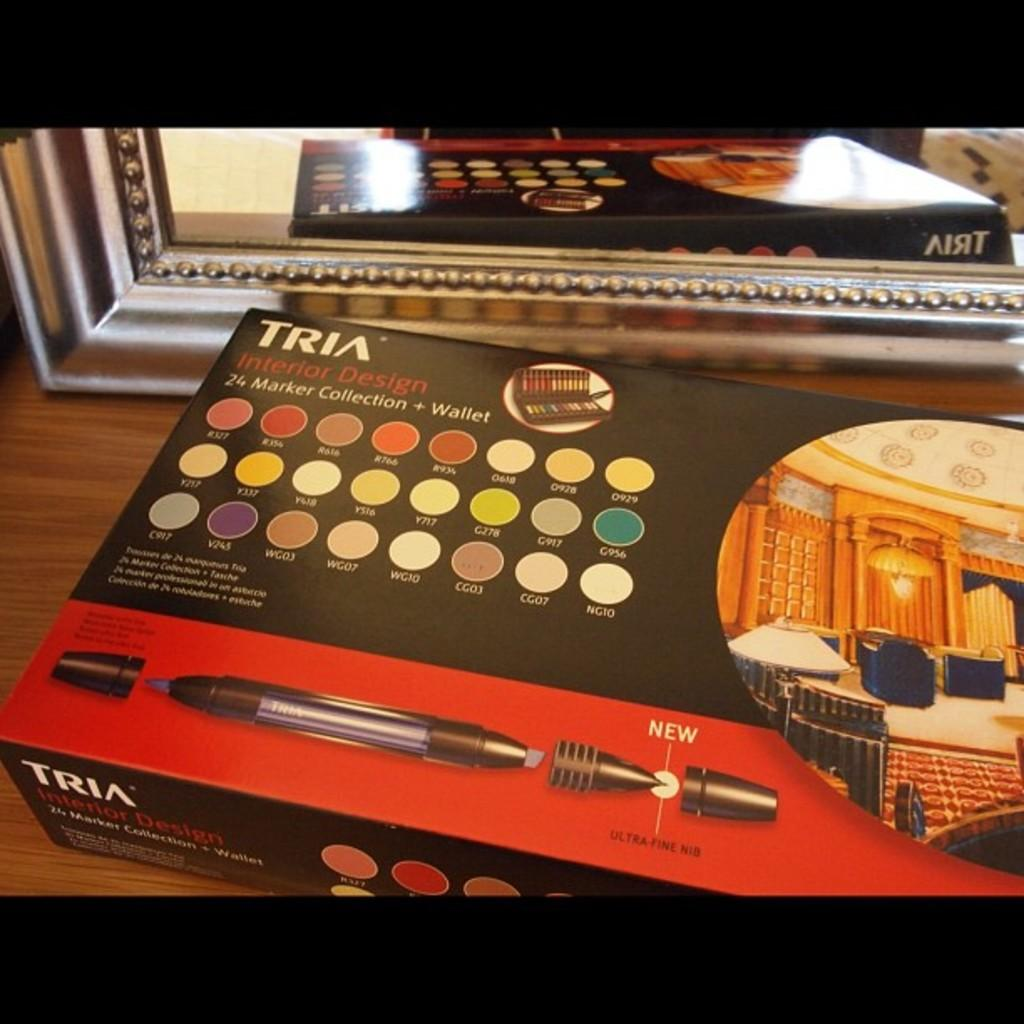Provide a one-sentence caption for the provided image. 24 colored interior design marker collection and wallet by Tria. 